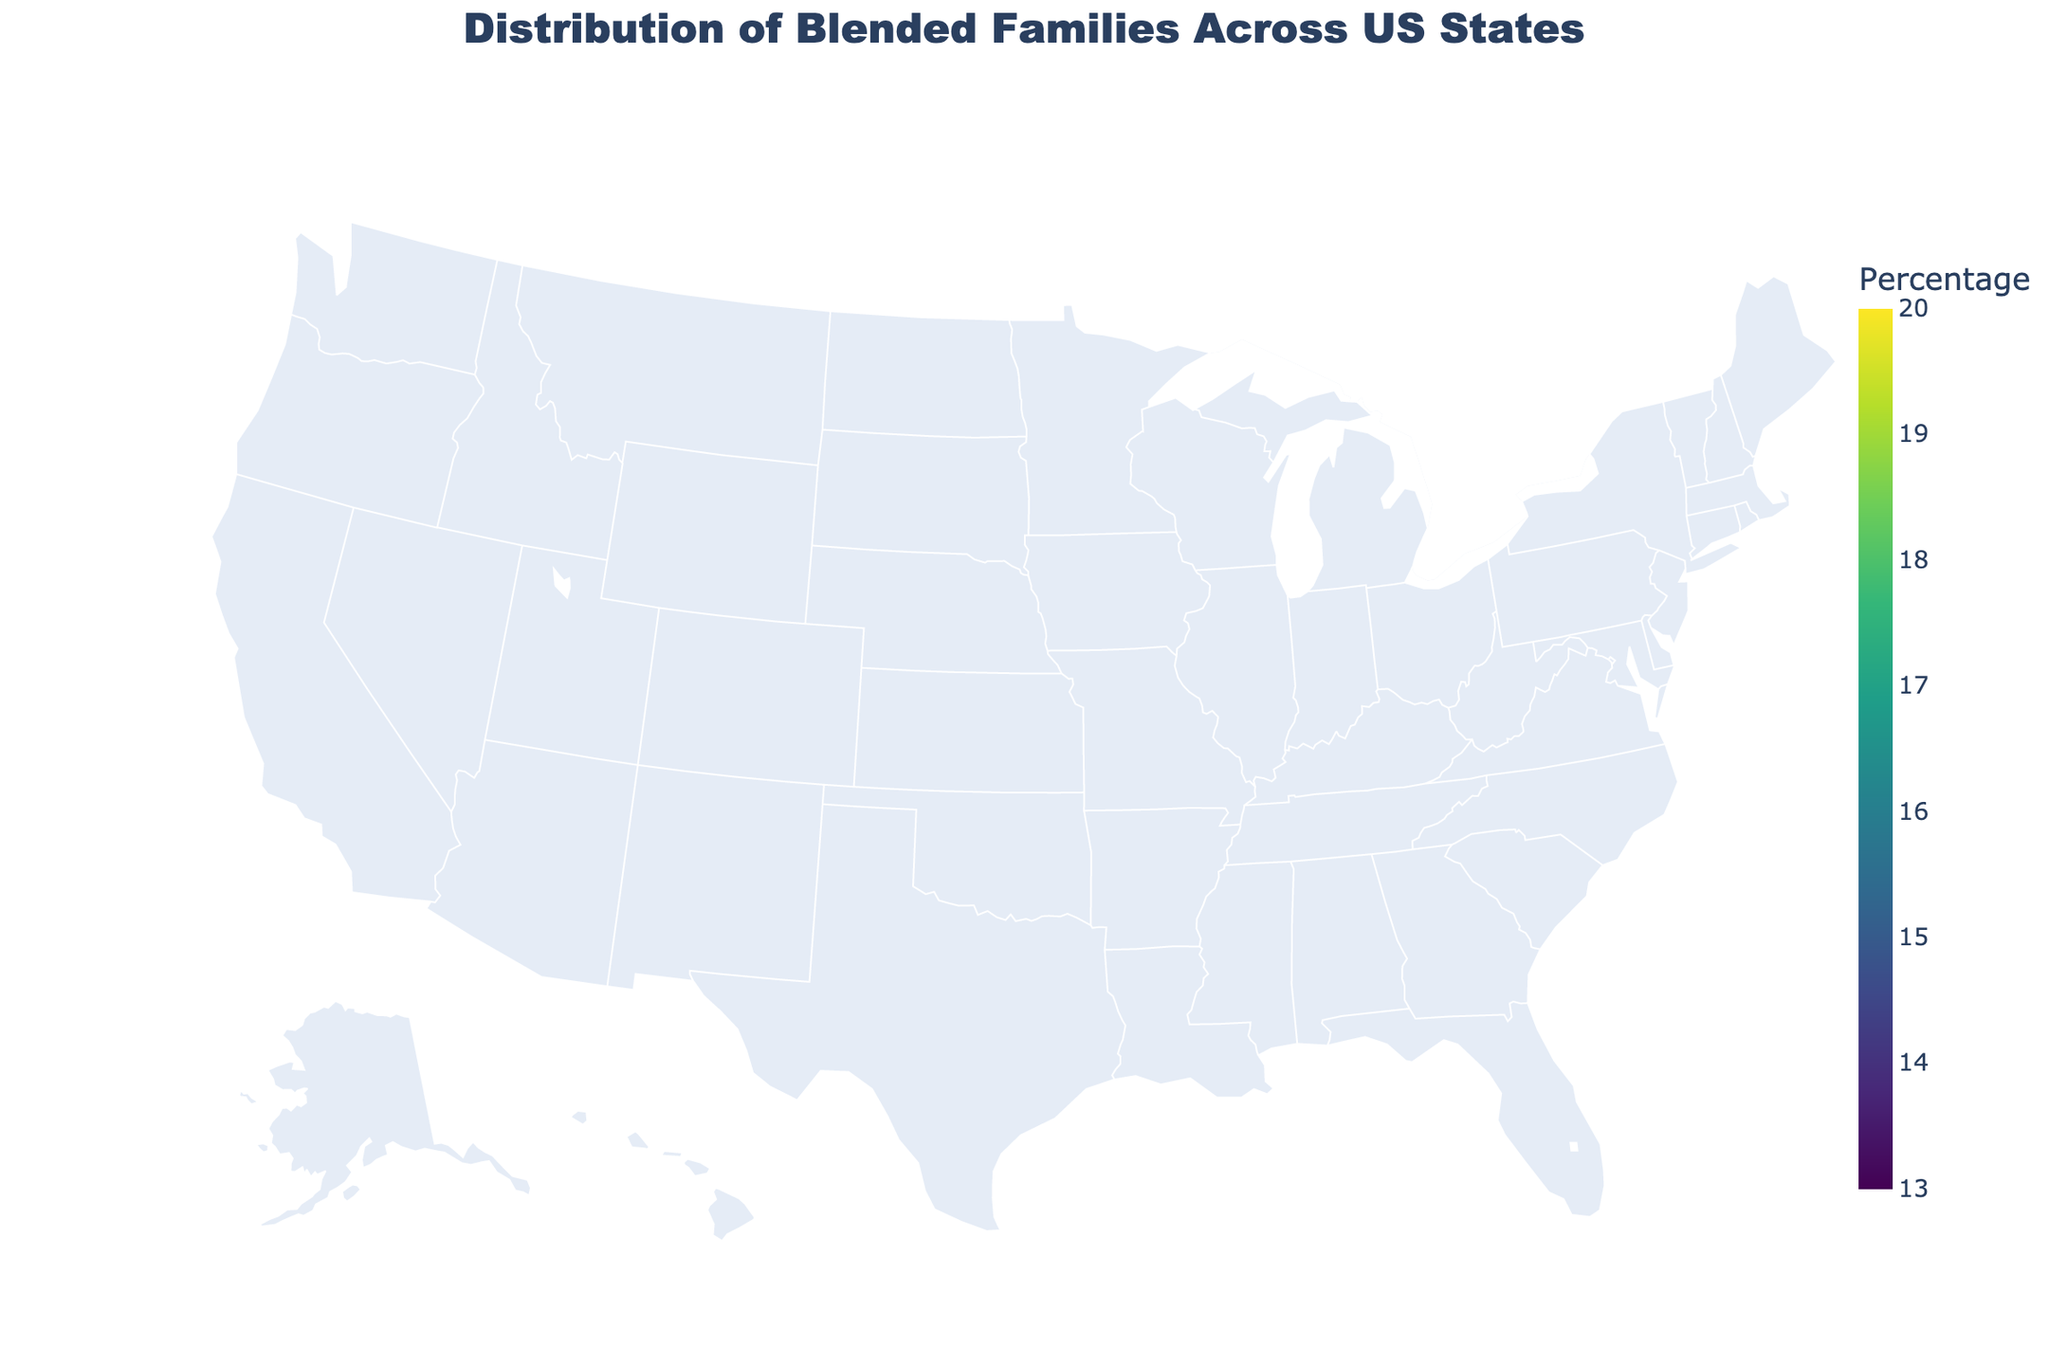What is the title of the plot? The title is displayed at the top center of the plot, which reads “Distribution of Blended Families Across US States”.
Answer: Distribution of Blended Families Across US States Which state has the highest percentage of blended families? By observing the color intensity on the map and the hover information, Tennessee has the highest percentage at 19.5%.
Answer: Tennessee Which state has the lowest percentage of blended families? The color intensity shows that Massachusetts has the lowest percentage at 13.2%.
Answer: Massachusetts What is the range of the color scale used in the plot? The color scale ranges from the lowest color at 13% to the highest color at 20%, as indicated in the legend of the map.
Answer: 13% to 20% Which states have percentages of blended families greater than or equal to 18%? States with darker colors and hover information reveal that Texas, Georgia, North Carolina, Arizona, Tennessee, Indiana, and Missouri have percentages greater than or equal to 18%.
Answer: Texas, Georgia, North Carolina, Arizona, Tennessee, Indiana, Missouri What is the median percentage of blended families among the displayed states? Sorting the percentages: 13.2, 13.8, 14.3, 15.3, 15.6, 15.9, 16.1, 16.4, 16.5, 16.7, 17.2, 17.5, 17.8, 18.1, 18.2, 18.4, 18.7, 18.9, 19.1, 19.5. The median is the middle value of this sorted list. Since there are 20 entries, the median is the average of the 10th and 11th values, (16.7 + 17.2) / 2.
Answer: 16.95% Compare the percentage of blended families in New York and Ohio. Which state has a higher percentage? The map shows that New York has 14.3% and Ohio has 17.5%. Comparing these two values, Ohio is higher than New York.
Answer: Ohio What is the average percentage of blended families across all states shown in the plot? Sum all percentages: 16.5 + 18.2 + 17.8 + 14.3 + 15.9 + 16.1 + 17.5 + 19.1 + 18.7 + 17.2 + 13.8 + 16.7 + 15.6 + 18.9 + 13.2 + 19.5 + 18.1 + 18.4 + 15.3 + 16.4 = 329.3. Divide by the number of states, which is 20. The average is 329.3 / 20.
Answer: 16.465% Which state has a percentage of blended families closest to the national average percentage calculated above? The closest state percentage to 16.465% is California, with 16.5% blended families.
Answer: California What color is associated with the highest percentage on the color scale? Observing the legend on the right side of the plot, the highest percentage of 20% corresponds to the darkest color displayed on the map, which is a dark shade of green.
Answer: Dark green 